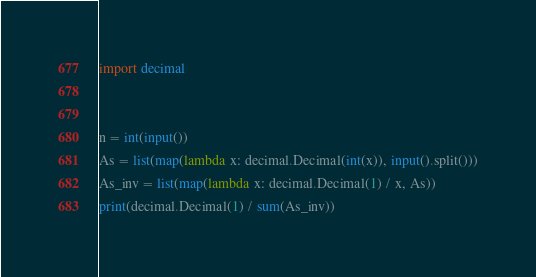<code> <loc_0><loc_0><loc_500><loc_500><_Python_>import decimal


n = int(input())
As = list(map(lambda x: decimal.Decimal(int(x)), input().split()))
As_inv = list(map(lambda x: decimal.Decimal(1) / x, As))
print(decimal.Decimal(1) / sum(As_inv))</code> 